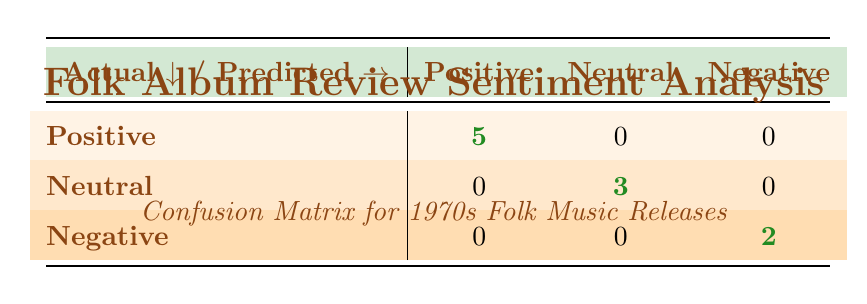What is the total number of positive album reviews? The table shows that there are 5 reviews classified as positive, as indicated in the "Positive" row under "Actual" where it shows 5.
Answer: 5 What is the number of negative reviews that were correctly predicted? The table indicates that there are 2 reviews in the "Negative" row under "Actual" that were accurately predicted as negative, which is reflected in the corresponding cell showing 2.
Answer: 2 Did any neutral reviews get misclassified as positive? Looking at the matrix, there are no predicted positive classifications for neutral reviews, which indicates that none were misclassified as positive.
Answer: No What is the total number of neutral album reviews in the dataset? The table shows 3 neutral reviews correctly identified, and since there are no misclassifications, the total number of neutral reviews is also 3.
Answer: 3 What percentage of the total reviews were classified as neutral? There are 10 total reviews (5 positive + 3 neutral + 2 negative). The neutral reviews account for 3 out of 10, so the percentage is (3/10) * 100 = 30%.
Answer: 30% Were there any positive reviews that were misclassified as negative? The table indicates that 5 positive reviews exist, and there are no instances of positive reviews predicted as negative, confirming that none were misclassified.
Answer: No What is the ratio of positive to negative reviews correctly identified? There are 5 positive reviews correctly identified and 2 negative reviews correctly identified. The ratio is therefore 5 to 2.
Answer: 5 to 2 How many reviews were found to be neutral and incorrectly classified? The table shows that there are 0 neutral reviews that were misclassified, reflecting accuracy in all neutral predictions.
Answer: 0 What is the total number of reviews represented in the confusion matrix? The total is the sum of all cells in the matrix: 5 (positive) + 3 (neutral) + 2 (negative) = 10 reviews in total.
Answer: 10 